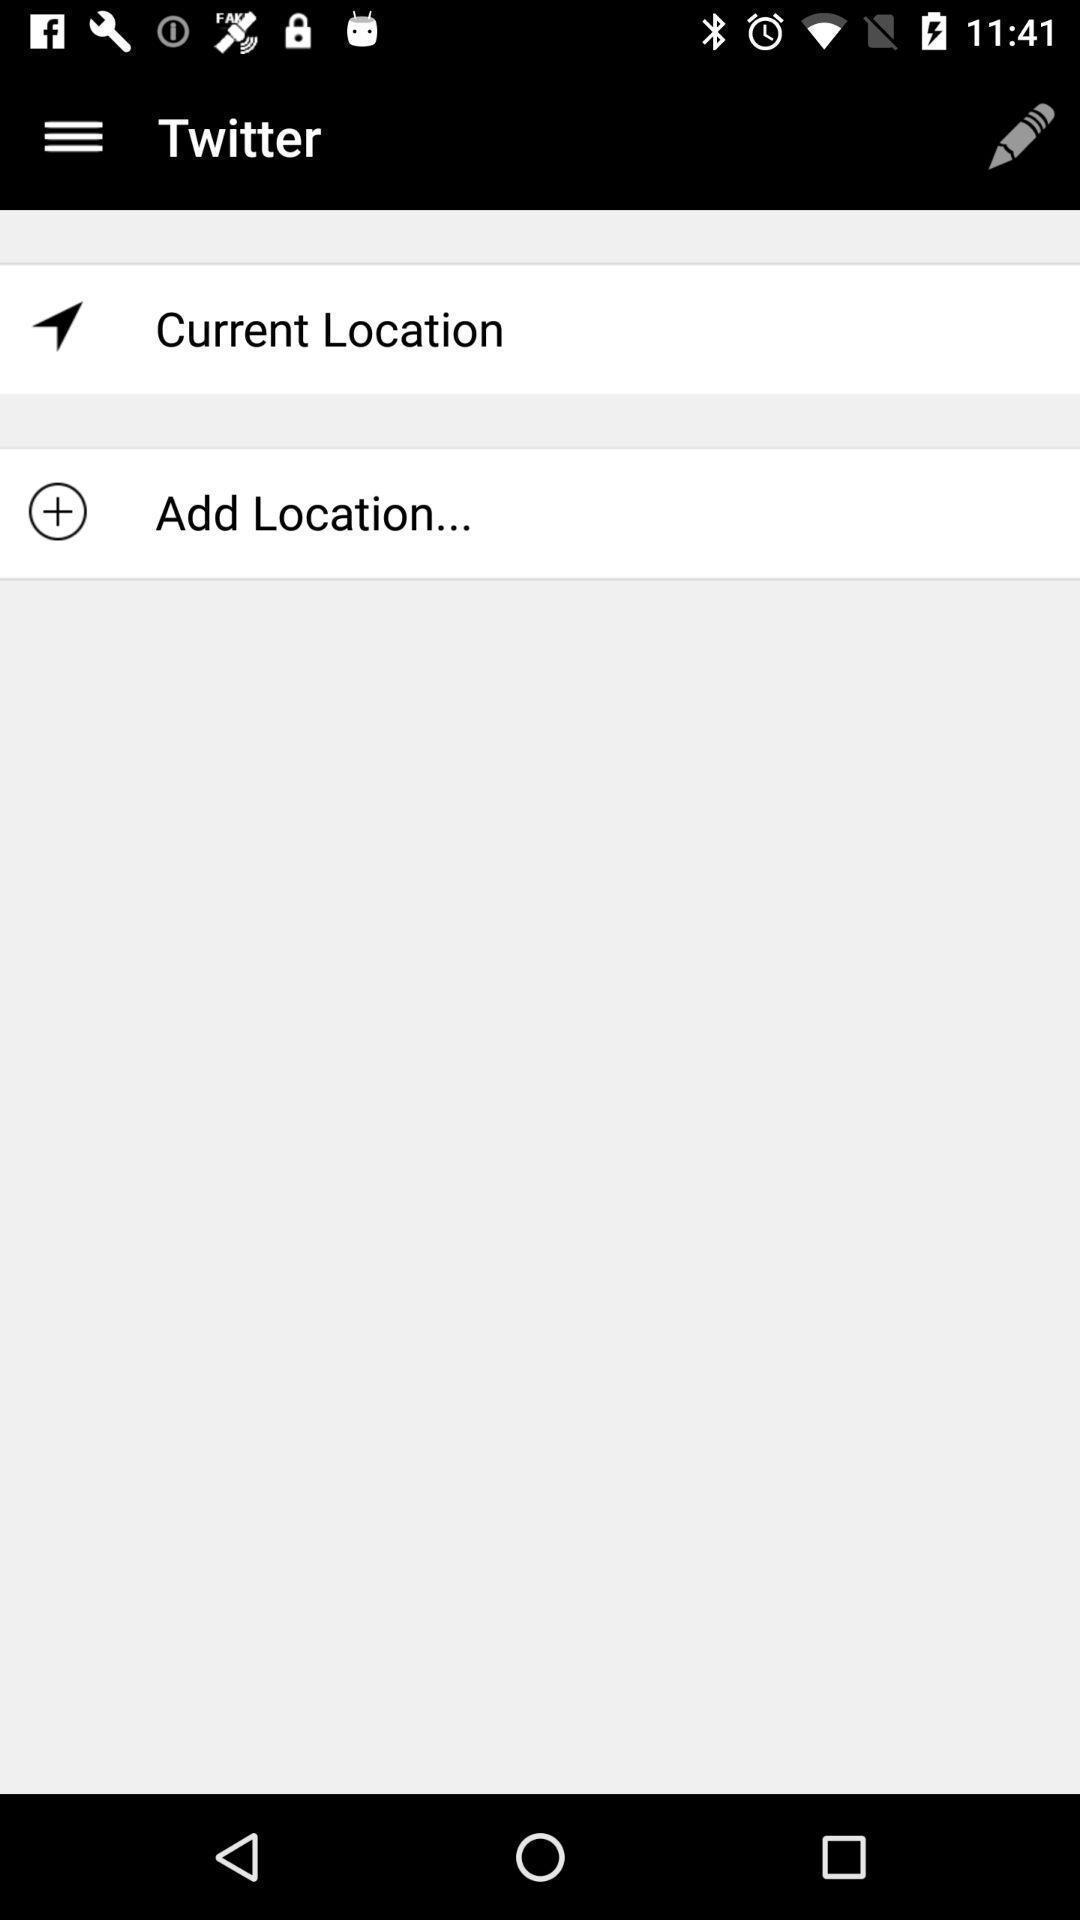Give me a narrative description of this picture. Page displayed to add location. 